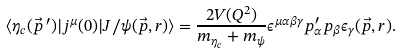Convert formula to latex. <formula><loc_0><loc_0><loc_500><loc_500>\langle \eta _ { c } ( \vec { p } \, ^ { \prime } ) | j ^ { \mu } ( 0 ) | J / \psi ( \vec { p } , r ) \rangle = \frac { 2 V ( Q ^ { 2 } ) } { m _ { \eta _ { c } } + m _ { \psi } } \epsilon ^ { \mu \alpha \beta \gamma } p ^ { \prime } _ { \alpha } p _ { \beta } \epsilon _ { \gamma } ( \vec { p } , r ) .</formula> 